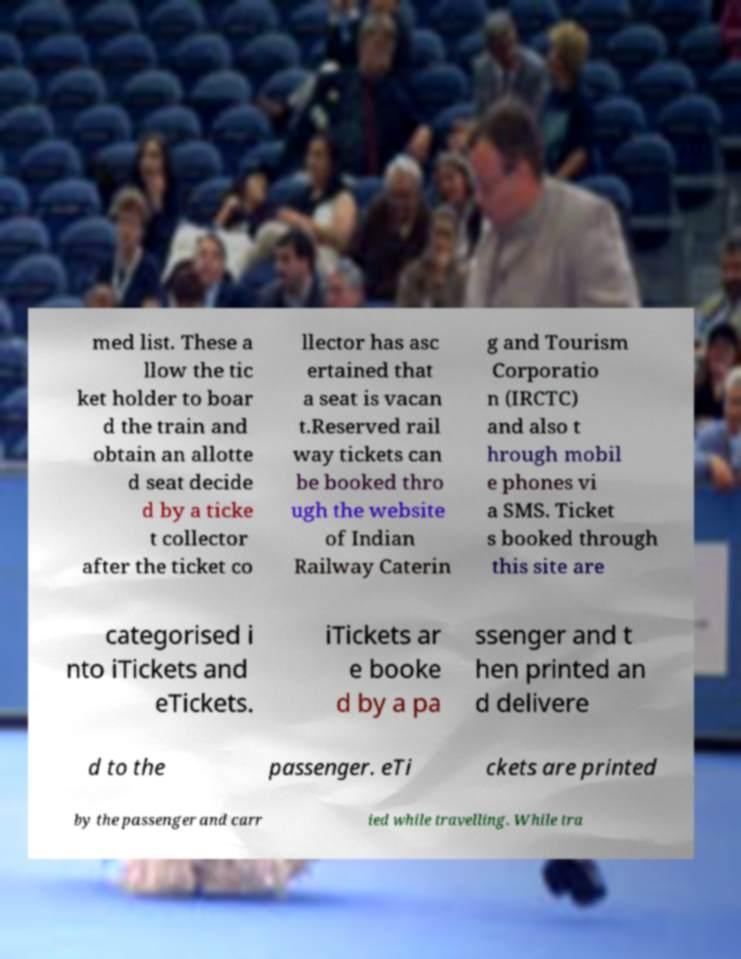There's text embedded in this image that I need extracted. Can you transcribe it verbatim? med list. These a llow the tic ket holder to boar d the train and obtain an allotte d seat decide d by a ticke t collector after the ticket co llector has asc ertained that a seat is vacan t.Reserved rail way tickets can be booked thro ugh the website of Indian Railway Caterin g and Tourism Corporatio n (IRCTC) and also t hrough mobil e phones vi a SMS. Ticket s booked through this site are categorised i nto iTickets and eTickets. iTickets ar e booke d by a pa ssenger and t hen printed an d delivere d to the passenger. eTi ckets are printed by the passenger and carr ied while travelling. While tra 